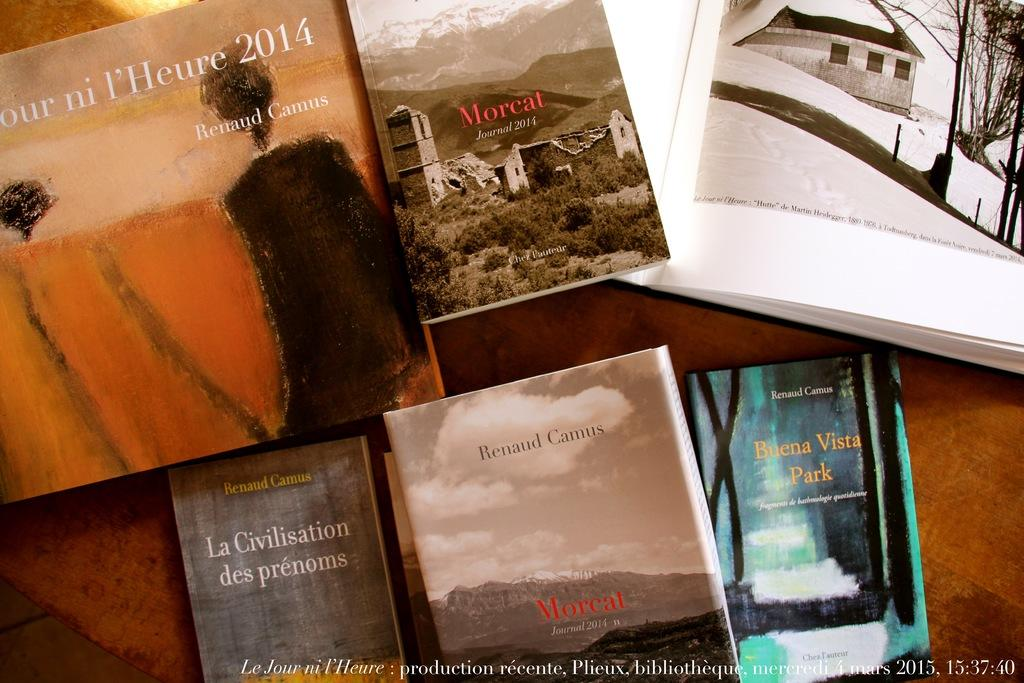<image>
Summarize the visual content of the image. books on a table include Morcat Journal 2014 